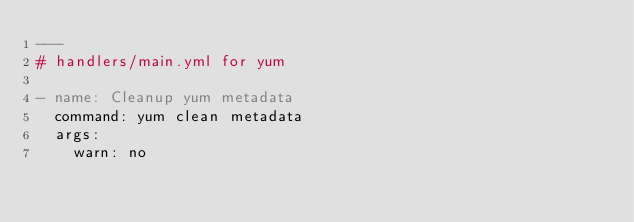<code> <loc_0><loc_0><loc_500><loc_500><_YAML_>---
# handlers/main.yml for yum

- name: Cleanup yum metadata
  command: yum clean metadata
  args:
    warn: no
</code> 